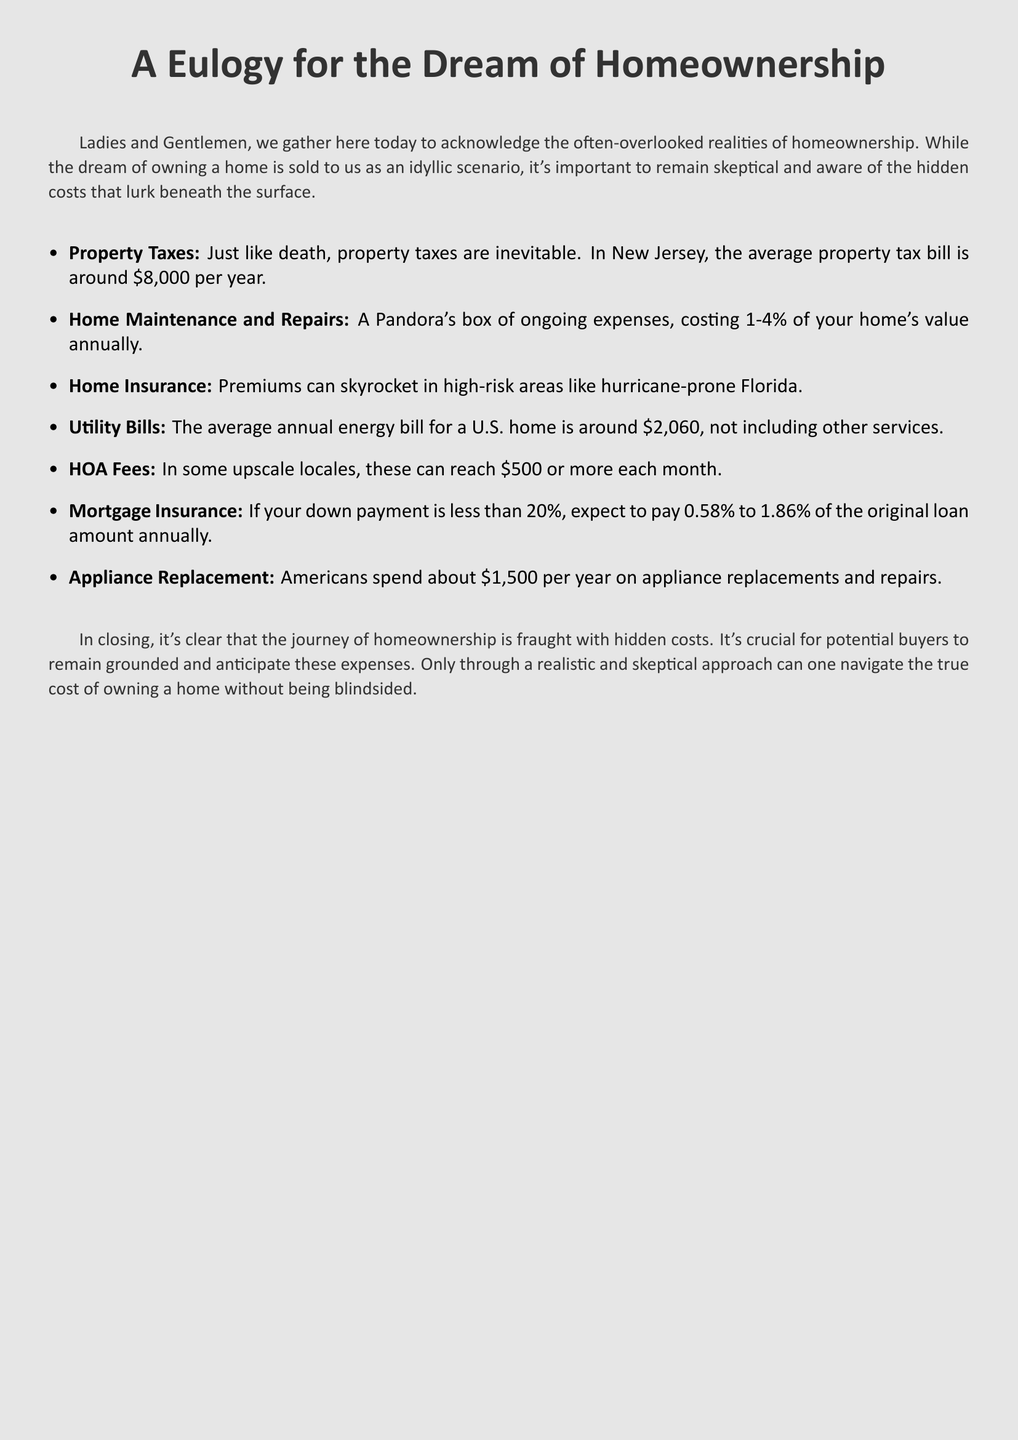What is the average property tax bill in New Jersey? The document states that the average property tax bill is around $8,000 per year.
Answer: $8,000 What percentage of a home's value do maintenance and repairs typically cost annually? According to the document, home maintenance and repairs can cost 1-4% of your home's value annually.
Answer: 1-4% What is the average annual energy bill for a U.S. home? The document mentions that the average annual energy bill for a U.S. home is around $2,060.
Answer: $2,060 What can HOA fees reach in some upscale locales? The document indicates that HOA fees can reach $500 or more each month.
Answer: $500 What percentage of the original loan amount does mortgage insurance cost for a down payment less than 20%? The document states that mortgage insurance can range from 0.58% to 1.86% of the original loan amount annually for a down payment of less than 20%.
Answer: 0.58% to 1.86% What theme does the eulogy focus on regarding homeownership? The document highlights the hidden costs of homeownership beyond just the mortgage.
Answer: Hidden costs What is the primary reason given for needing to remain skeptical about homeownership? The document suggests that potential buyers should anticipate hidden expenses to avoid being blindsided.
Answer: Anticipate hidden expenses What type of expenses does the eulogy refer to that are often considered a "Pandora's box"? The document refers to home maintenance and repairs as a "Pandora's box" of ongoing expenses.
Answer: Home maintenance and repairs What is a common annual expense mentioned for appliance-related upkeep? The document states that Americans spend about $1,500 per year on appliance replacements and repairs.
Answer: $1,500 